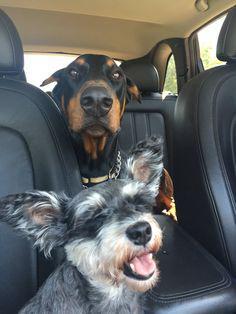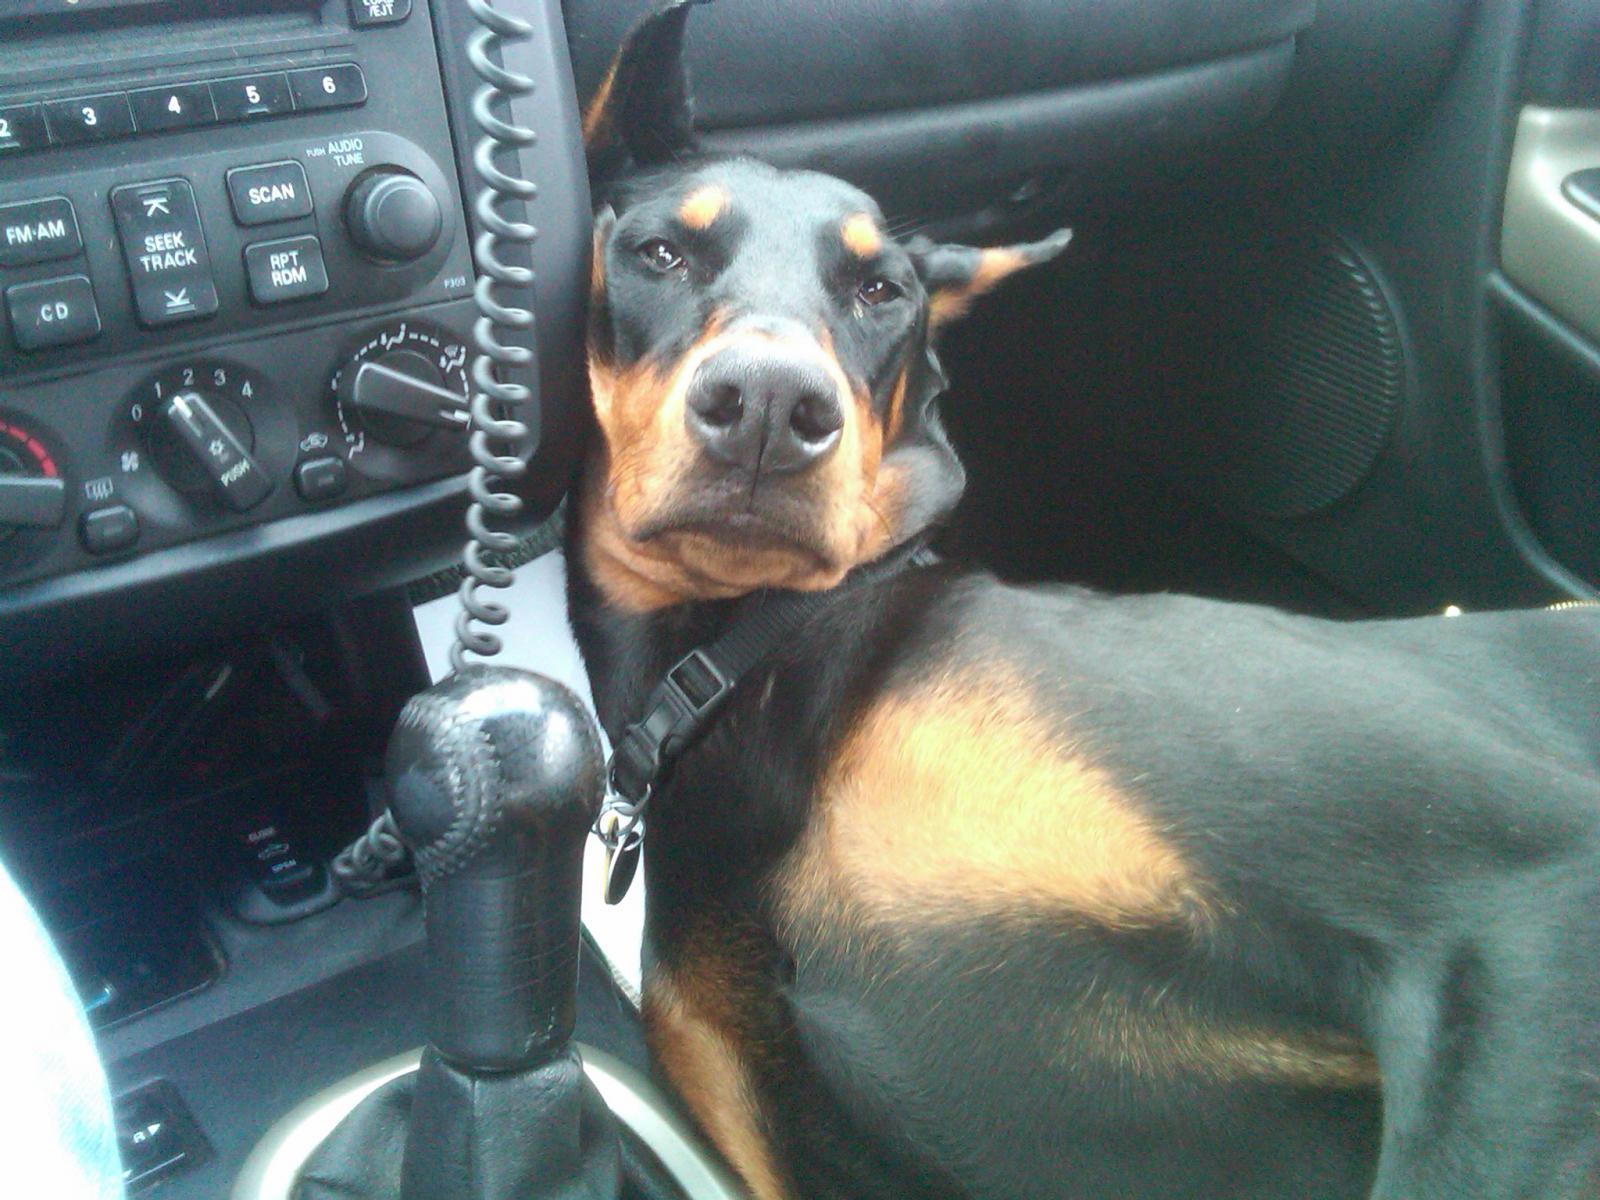The first image is the image on the left, the second image is the image on the right. For the images displayed, is the sentence "There are exactly three dogs in total." factually correct? Answer yes or no. Yes. The first image is the image on the left, the second image is the image on the right. Examine the images to the left and right. Is the description "There are 3 dogs in cars." accurate? Answer yes or no. Yes. 